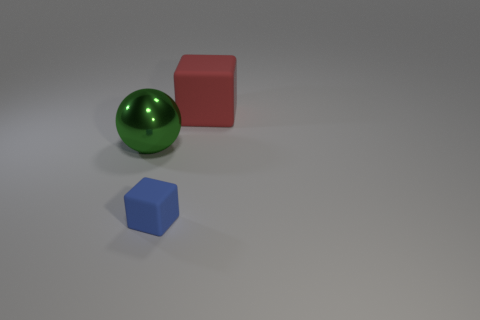Add 2 big yellow rubber cylinders. How many objects exist? 5 Subtract all cubes. How many objects are left? 1 Subtract all gray cubes. Subtract all cyan spheres. How many cubes are left? 2 Subtract all yellow cylinders. How many red blocks are left? 1 Subtract 0 blue cylinders. How many objects are left? 3 Subtract all tiny red rubber spheres. Subtract all big matte cubes. How many objects are left? 2 Add 3 green things. How many green things are left? 4 Add 1 large brown rubber spheres. How many large brown rubber spheres exist? 1 